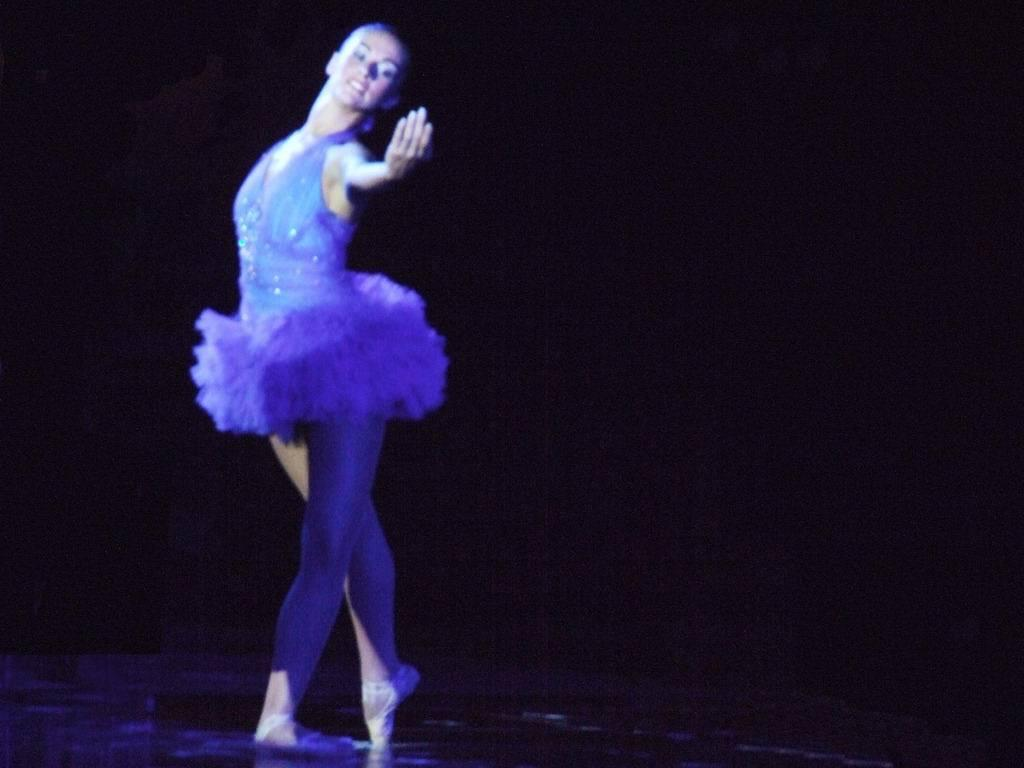Who is the main subject in the image? There is a woman in the image. What is the woman doing in the image? The woman is dancing on the floor. Can you describe the background of the image? The background of the image is dark. What is the woman's tendency to use a scale in the image? There is no mention of a scale in the image, so it is not possible to determine the woman's tendency to use one. 